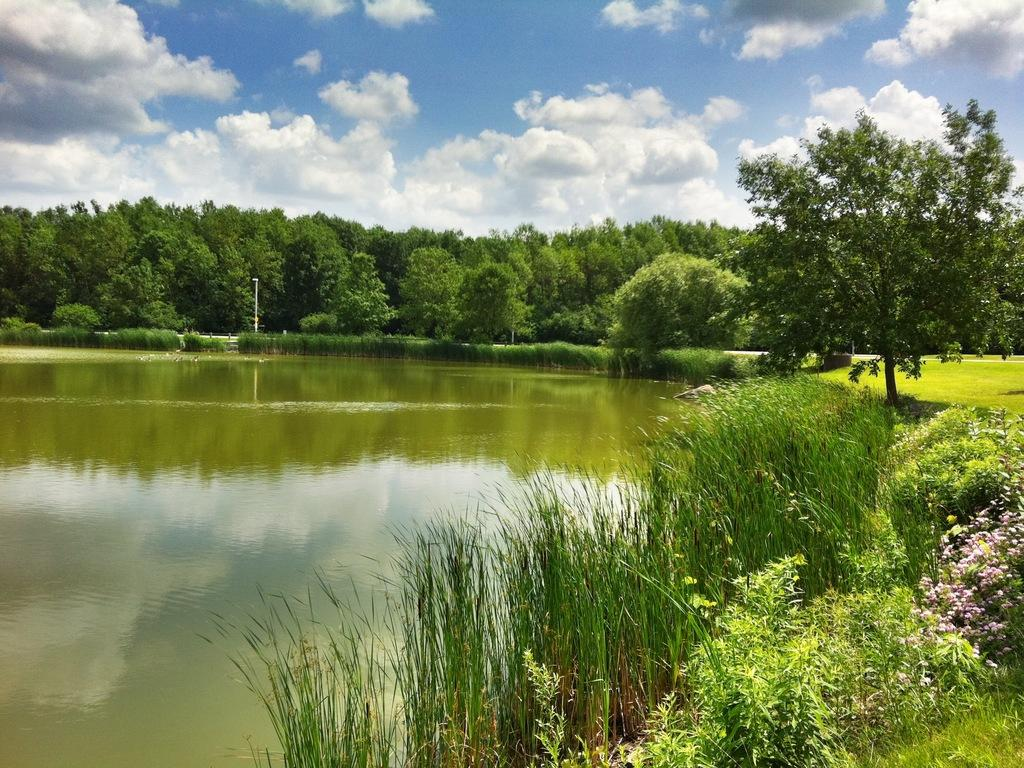What is one of the natural elements present in the image? There is water in the image. What type of vegetation can be seen in the image? There is grass, plants, and pink flowers in the image. What is visible in the background of the image? There are trees, a pole, and the sky in the background of the image. What type of silver crook does the father use in the image? There is no father, silver, or crook present in the image. 